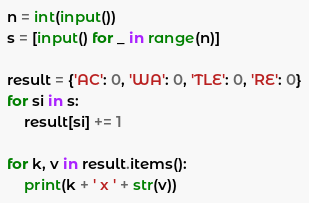Convert code to text. <code><loc_0><loc_0><loc_500><loc_500><_Python_>n = int(input())
s = [input() for _ in range(n)]

result = {'AC': 0, 'WA': 0, 'TLE': 0, 'RE': 0}
for si in s:
    result[si] += 1

for k, v in result.items():
    print(k + ' x ' + str(v))</code> 